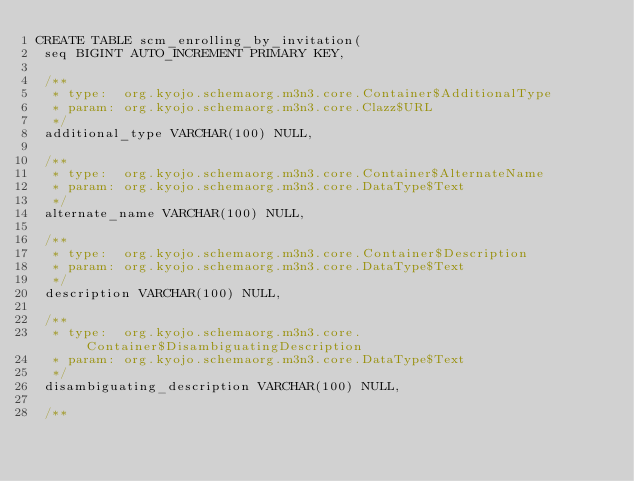<code> <loc_0><loc_0><loc_500><loc_500><_SQL_>CREATE TABLE scm_enrolling_by_invitation(
 seq BIGINT AUTO_INCREMENT PRIMARY KEY,

 /**
  * type:  org.kyojo.schemaorg.m3n3.core.Container$AdditionalType
  * param: org.kyojo.schemaorg.m3n3.core.Clazz$URL
  */
 additional_type VARCHAR(100) NULL,

 /**
  * type:  org.kyojo.schemaorg.m3n3.core.Container$AlternateName
  * param: org.kyojo.schemaorg.m3n3.core.DataType$Text
  */
 alternate_name VARCHAR(100) NULL,

 /**
  * type:  org.kyojo.schemaorg.m3n3.core.Container$Description
  * param: org.kyojo.schemaorg.m3n3.core.DataType$Text
  */
 description VARCHAR(100) NULL,

 /**
  * type:  org.kyojo.schemaorg.m3n3.core.Container$DisambiguatingDescription
  * param: org.kyojo.schemaorg.m3n3.core.DataType$Text
  */
 disambiguating_description VARCHAR(100) NULL,

 /**</code> 